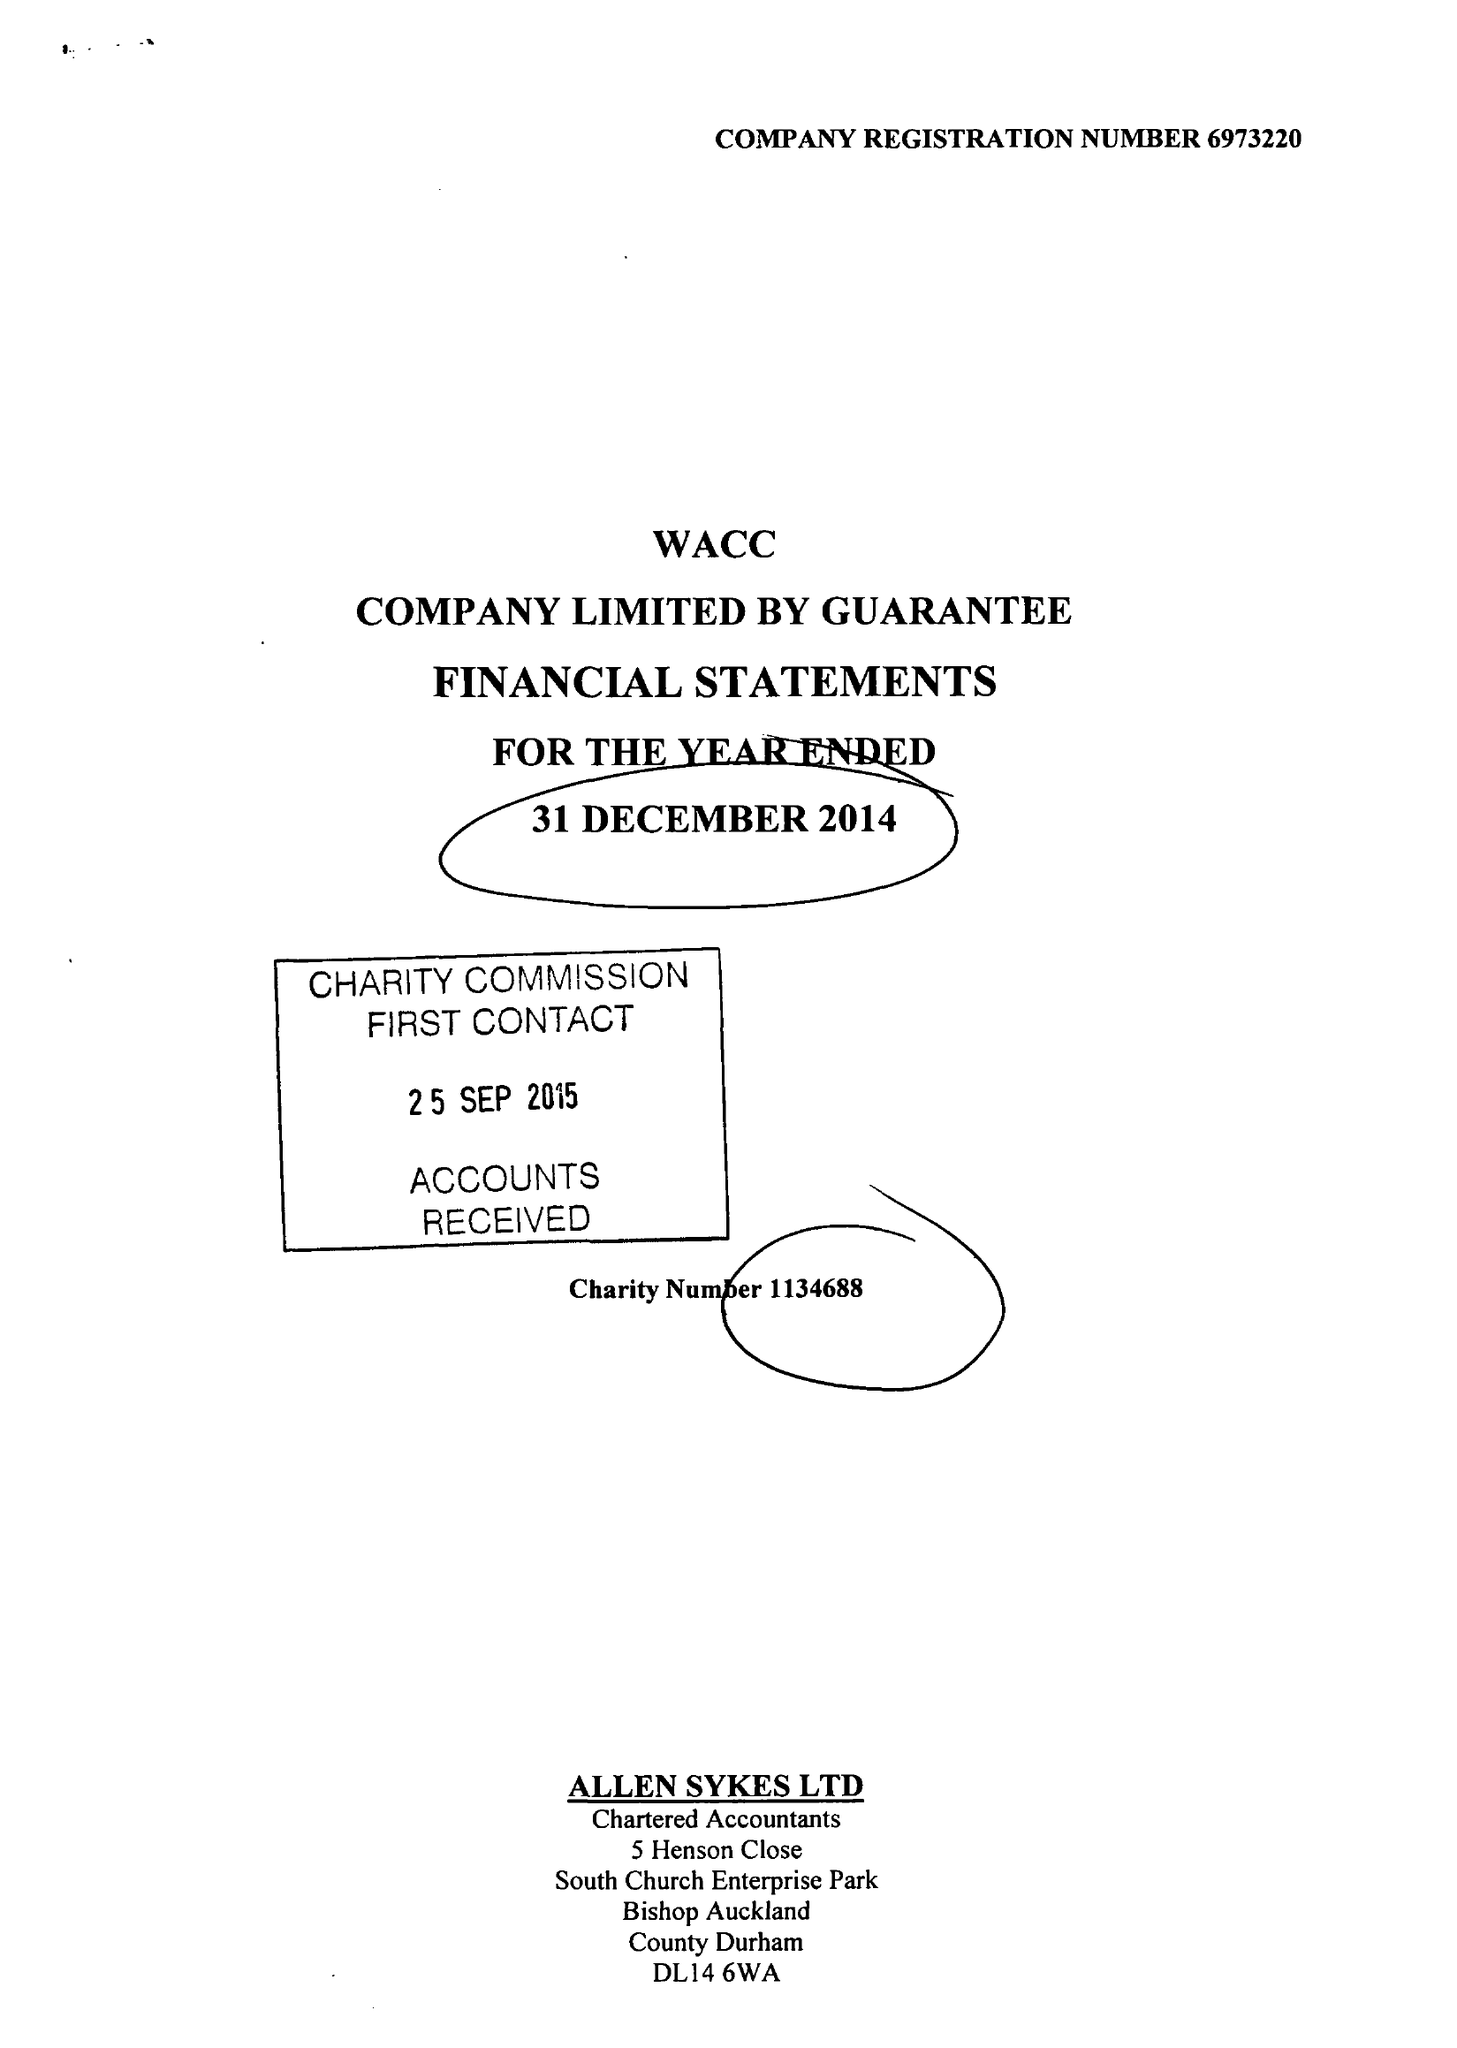What is the value for the charity_number?
Answer the question using a single word or phrase. 1134688 